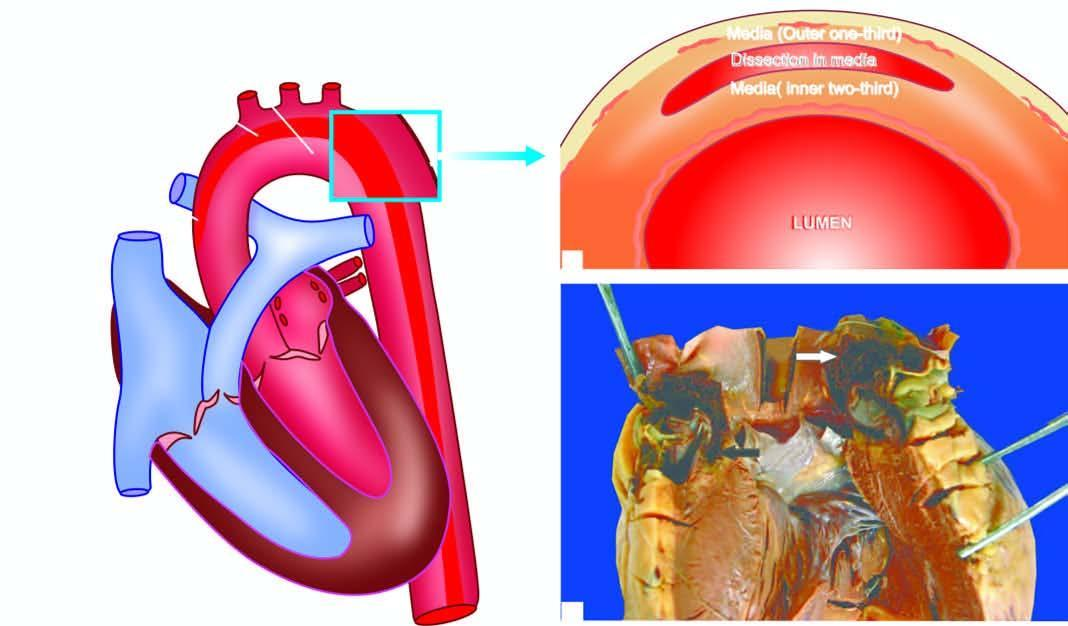s the ascending aorta seen with the heart?
Answer the question using a single word or phrase. Yes 